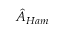<formula> <loc_0><loc_0><loc_500><loc_500>\hat { A } _ { H a m }</formula> 